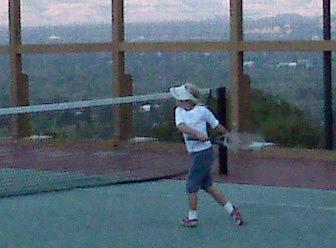Is the woman wearing a skirt or shorts?
Write a very short answer. Shorts. What is the fence made of?
Keep it brief. Wood. Where is this tennis court?
Write a very short answer. Outside. What is the person wearing on their head?
Answer briefly. Visor. Is the person holding the tennis racket on his left hand?
Write a very short answer. No. 